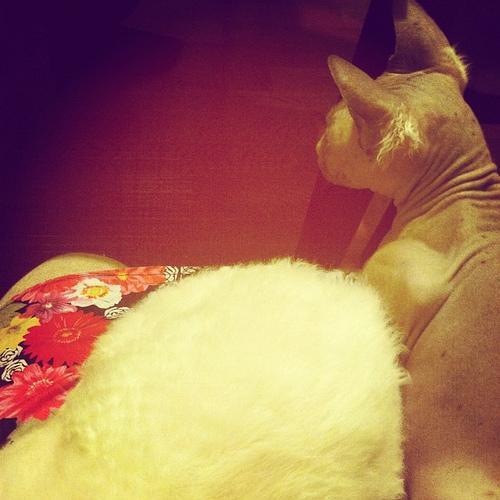How many ears does the cat have?
Give a very brief answer. 2. 